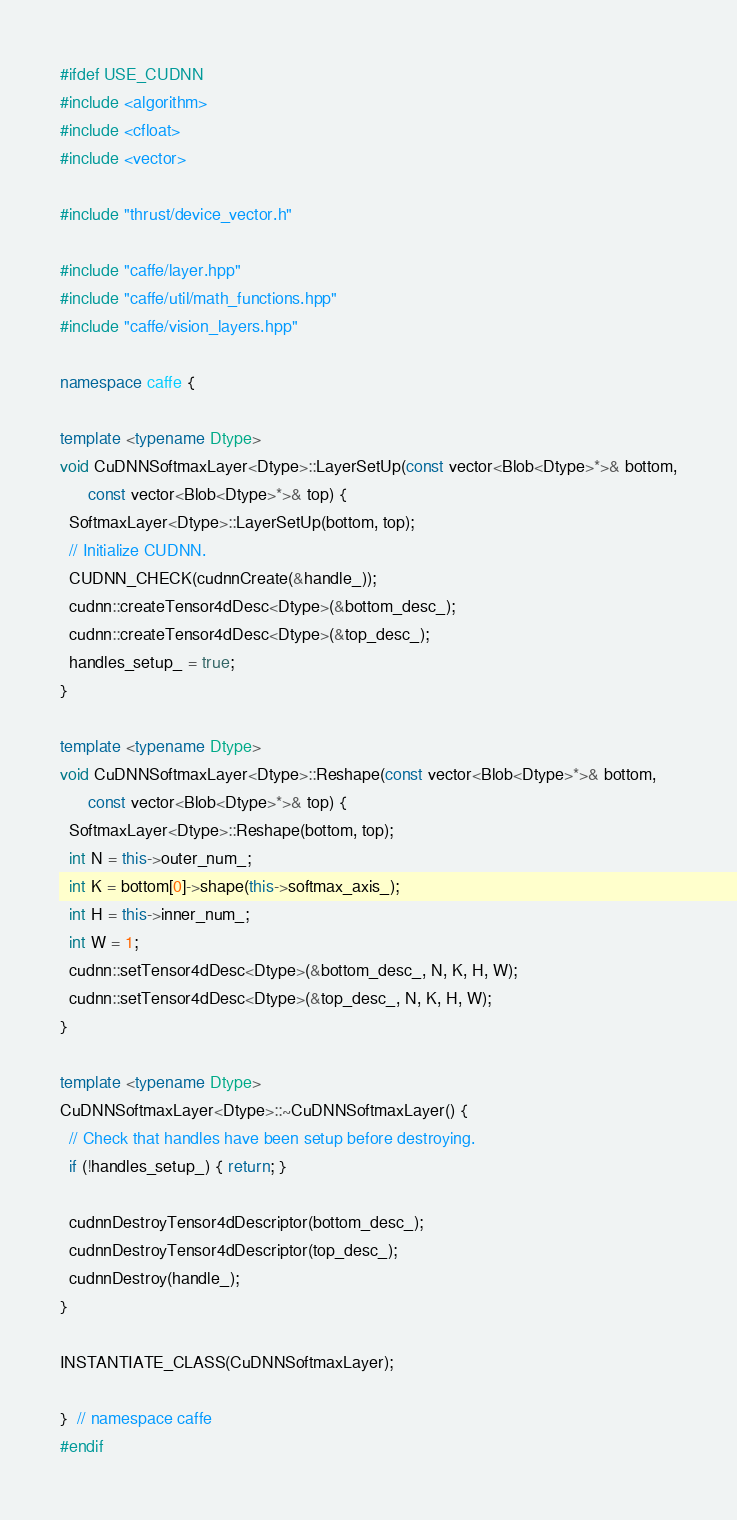<code> <loc_0><loc_0><loc_500><loc_500><_C++_>#ifdef USE_CUDNN
#include <algorithm>
#include <cfloat>
#include <vector>

#include "thrust/device_vector.h"

#include "caffe/layer.hpp"
#include "caffe/util/math_functions.hpp"
#include "caffe/vision_layers.hpp"

namespace caffe {

template <typename Dtype>
void CuDNNSoftmaxLayer<Dtype>::LayerSetUp(const vector<Blob<Dtype>*>& bottom,
      const vector<Blob<Dtype>*>& top) {
  SoftmaxLayer<Dtype>::LayerSetUp(bottom, top);
  // Initialize CUDNN.
  CUDNN_CHECK(cudnnCreate(&handle_));
  cudnn::createTensor4dDesc<Dtype>(&bottom_desc_);
  cudnn::createTensor4dDesc<Dtype>(&top_desc_);
  handles_setup_ = true;
}

template <typename Dtype>
void CuDNNSoftmaxLayer<Dtype>::Reshape(const vector<Blob<Dtype>*>& bottom,
      const vector<Blob<Dtype>*>& top) {
  SoftmaxLayer<Dtype>::Reshape(bottom, top);
  int N = this->outer_num_;
  int K = bottom[0]->shape(this->softmax_axis_);
  int H = this->inner_num_;
  int W = 1;
  cudnn::setTensor4dDesc<Dtype>(&bottom_desc_, N, K, H, W);
  cudnn::setTensor4dDesc<Dtype>(&top_desc_, N, K, H, W);
}

template <typename Dtype>
CuDNNSoftmaxLayer<Dtype>::~CuDNNSoftmaxLayer() {
  // Check that handles have been setup before destroying.
  if (!handles_setup_) { return; }

  cudnnDestroyTensor4dDescriptor(bottom_desc_);
  cudnnDestroyTensor4dDescriptor(top_desc_);
  cudnnDestroy(handle_);
}

INSTANTIATE_CLASS(CuDNNSoftmaxLayer);

}  // namespace caffe
#endif
</code> 